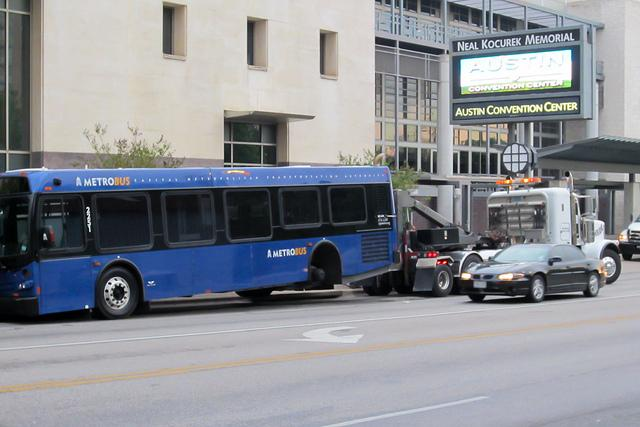In which state is this bus being towed?

Choices:
A) texas
B) new mexico
C) kansas
D) mass texas 